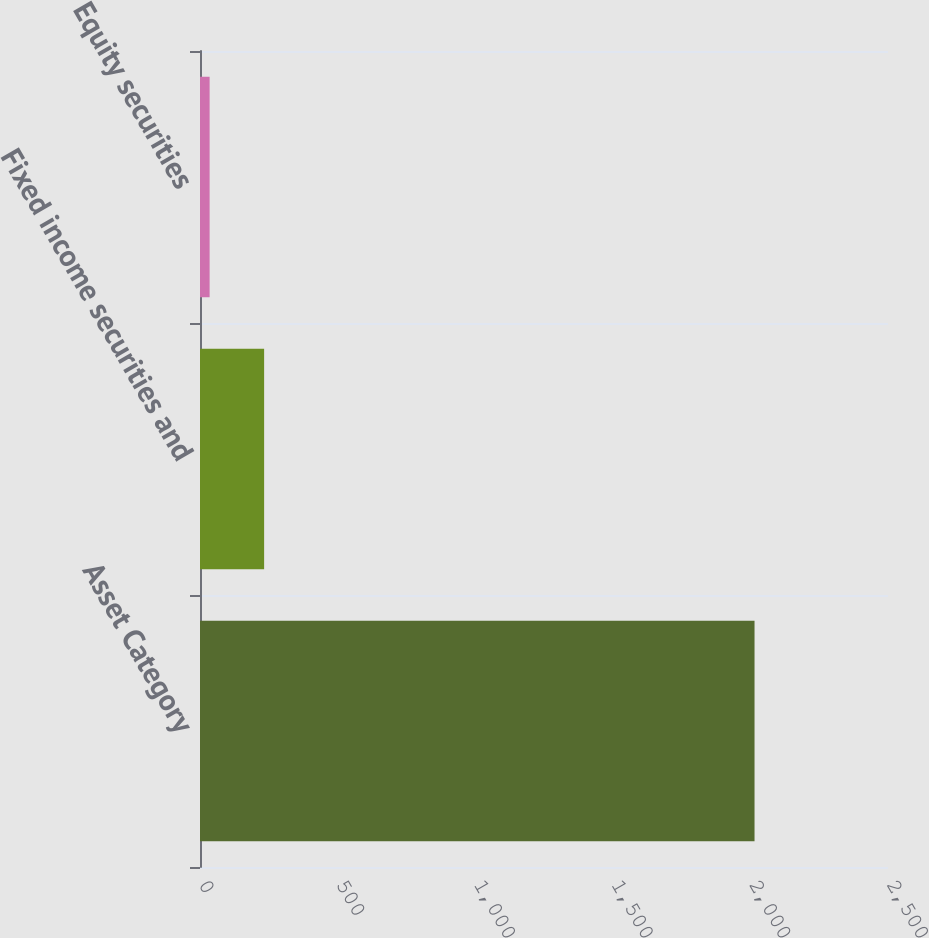Convert chart to OTSL. <chart><loc_0><loc_0><loc_500><loc_500><bar_chart><fcel>Asset Category<fcel>Fixed income securities and<fcel>Equity securities<nl><fcel>2015<fcel>233<fcel>35<nl></chart> 